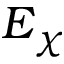<formula> <loc_0><loc_0><loc_500><loc_500>E _ { \chi }</formula> 